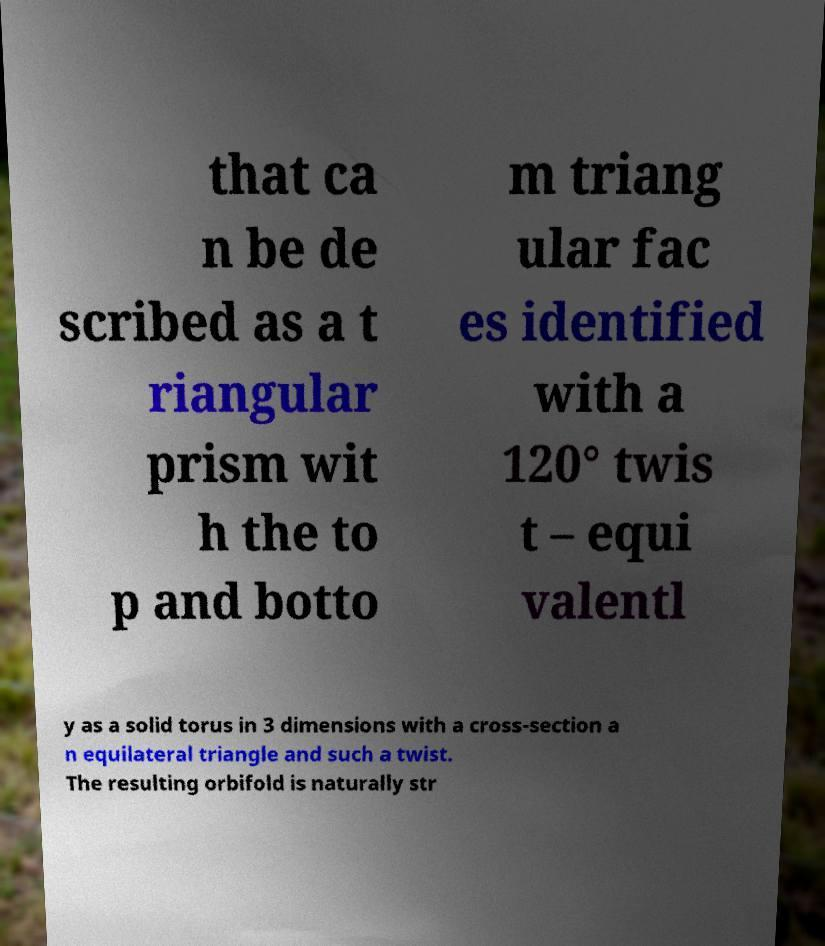Can you read and provide the text displayed in the image?This photo seems to have some interesting text. Can you extract and type it out for me? that ca n be de scribed as a t riangular prism wit h the to p and botto m triang ular fac es identified with a 120° twis t – equi valentl y as a solid torus in 3 dimensions with a cross-section a n equilateral triangle and such a twist. The resulting orbifold is naturally str 